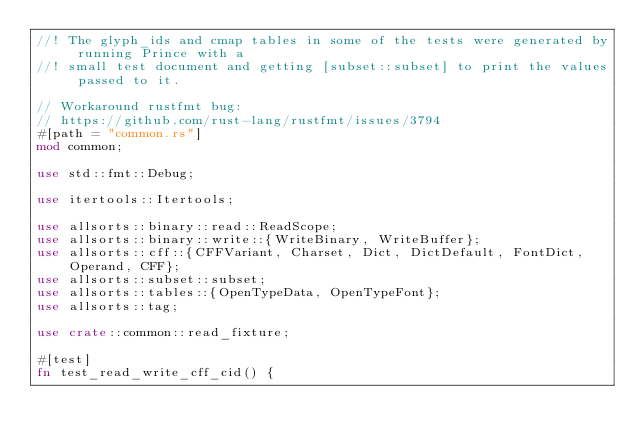Convert code to text. <code><loc_0><loc_0><loc_500><loc_500><_Rust_>//! The glyph_ids and cmap tables in some of the tests were generated by running Prince with a
//! small test document and getting [subset::subset] to print the values passed to it.

// Workaround rustfmt bug:
// https://github.com/rust-lang/rustfmt/issues/3794
#[path = "common.rs"]
mod common;

use std::fmt::Debug;

use itertools::Itertools;

use allsorts::binary::read::ReadScope;
use allsorts::binary::write::{WriteBinary, WriteBuffer};
use allsorts::cff::{CFFVariant, Charset, Dict, DictDefault, FontDict, Operand, CFF};
use allsorts::subset::subset;
use allsorts::tables::{OpenTypeData, OpenTypeFont};
use allsorts::tag;

use crate::common::read_fixture;

#[test]
fn test_read_write_cff_cid() {</code> 